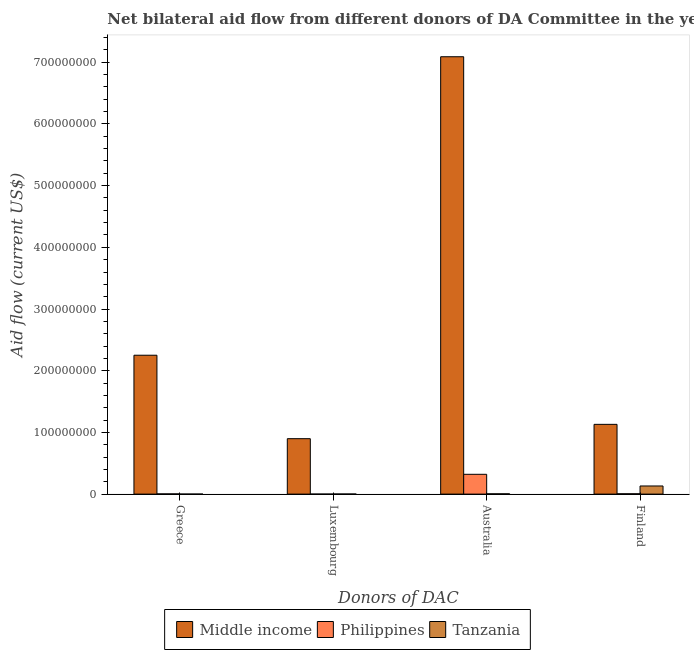How many different coloured bars are there?
Offer a terse response. 3. Are the number of bars per tick equal to the number of legend labels?
Ensure brevity in your answer.  Yes. Are the number of bars on each tick of the X-axis equal?
Your answer should be compact. Yes. How many bars are there on the 4th tick from the left?
Offer a very short reply. 3. How many bars are there on the 3rd tick from the right?
Your response must be concise. 3. What is the label of the 2nd group of bars from the left?
Give a very brief answer. Luxembourg. What is the amount of aid given by luxembourg in Middle income?
Offer a terse response. 8.98e+07. Across all countries, what is the maximum amount of aid given by finland?
Offer a terse response. 1.13e+08. Across all countries, what is the minimum amount of aid given by luxembourg?
Your answer should be very brief. 10000. In which country was the amount of aid given by luxembourg minimum?
Ensure brevity in your answer.  Philippines. What is the total amount of aid given by greece in the graph?
Keep it short and to the point. 2.25e+08. What is the difference between the amount of aid given by finland in Tanzania and that in Philippines?
Make the answer very short. 1.26e+07. What is the difference between the amount of aid given by greece in Middle income and the amount of aid given by finland in Tanzania?
Give a very brief answer. 2.12e+08. What is the average amount of aid given by australia per country?
Offer a very short reply. 2.47e+08. What is the difference between the amount of aid given by finland and amount of aid given by greece in Tanzania?
Ensure brevity in your answer.  1.32e+07. What is the ratio of the amount of aid given by australia in Middle income to that in Philippines?
Give a very brief answer. 22.1. What is the difference between the highest and the second highest amount of aid given by luxembourg?
Offer a terse response. 8.97e+07. What is the difference between the highest and the lowest amount of aid given by greece?
Offer a terse response. 2.25e+08. Is the sum of the amount of aid given by finland in Philippines and Tanzania greater than the maximum amount of aid given by greece across all countries?
Offer a very short reply. No. Is it the case that in every country, the sum of the amount of aid given by luxembourg and amount of aid given by greece is greater than the sum of amount of aid given by australia and amount of aid given by finland?
Offer a terse response. No. Are all the bars in the graph horizontal?
Keep it short and to the point. No. Are the values on the major ticks of Y-axis written in scientific E-notation?
Provide a short and direct response. No. Does the graph contain any zero values?
Offer a very short reply. No. Does the graph contain grids?
Give a very brief answer. No. Where does the legend appear in the graph?
Your response must be concise. Bottom center. How many legend labels are there?
Your answer should be very brief. 3. How are the legend labels stacked?
Provide a succinct answer. Horizontal. What is the title of the graph?
Your answer should be compact. Net bilateral aid flow from different donors of DA Committee in the year 2003. Does "Lower middle income" appear as one of the legend labels in the graph?
Provide a short and direct response. No. What is the label or title of the X-axis?
Provide a short and direct response. Donors of DAC. What is the label or title of the Y-axis?
Offer a very short reply. Aid flow (current US$). What is the Aid flow (current US$) in Middle income in Greece?
Make the answer very short. 2.25e+08. What is the Aid flow (current US$) of Philippines in Greece?
Offer a terse response. 3.20e+05. What is the Aid flow (current US$) in Middle income in Luxembourg?
Your answer should be compact. 8.98e+07. What is the Aid flow (current US$) of Philippines in Luxembourg?
Provide a short and direct response. 10000. What is the Aid flow (current US$) in Tanzania in Luxembourg?
Ensure brevity in your answer.  1.40e+05. What is the Aid flow (current US$) of Middle income in Australia?
Your response must be concise. 7.09e+08. What is the Aid flow (current US$) in Philippines in Australia?
Offer a terse response. 3.21e+07. What is the Aid flow (current US$) in Middle income in Finland?
Provide a succinct answer. 1.13e+08. What is the Aid flow (current US$) of Philippines in Finland?
Offer a very short reply. 5.40e+05. What is the Aid flow (current US$) in Tanzania in Finland?
Offer a very short reply. 1.32e+07. Across all Donors of DAC, what is the maximum Aid flow (current US$) of Middle income?
Give a very brief answer. 7.09e+08. Across all Donors of DAC, what is the maximum Aid flow (current US$) in Philippines?
Give a very brief answer. 3.21e+07. Across all Donors of DAC, what is the maximum Aid flow (current US$) of Tanzania?
Your answer should be very brief. 1.32e+07. Across all Donors of DAC, what is the minimum Aid flow (current US$) in Middle income?
Offer a terse response. 8.98e+07. Across all Donors of DAC, what is the minimum Aid flow (current US$) in Philippines?
Ensure brevity in your answer.  10000. What is the total Aid flow (current US$) in Middle income in the graph?
Ensure brevity in your answer.  1.14e+09. What is the total Aid flow (current US$) of Philippines in the graph?
Ensure brevity in your answer.  3.30e+07. What is the total Aid flow (current US$) in Tanzania in the graph?
Provide a short and direct response. 1.38e+07. What is the difference between the Aid flow (current US$) in Middle income in Greece and that in Luxembourg?
Your answer should be compact. 1.35e+08. What is the difference between the Aid flow (current US$) in Philippines in Greece and that in Luxembourg?
Ensure brevity in your answer.  3.10e+05. What is the difference between the Aid flow (current US$) of Tanzania in Greece and that in Luxembourg?
Ensure brevity in your answer.  -1.20e+05. What is the difference between the Aid flow (current US$) of Middle income in Greece and that in Australia?
Provide a short and direct response. -4.84e+08. What is the difference between the Aid flow (current US$) of Philippines in Greece and that in Australia?
Make the answer very short. -3.18e+07. What is the difference between the Aid flow (current US$) of Tanzania in Greece and that in Australia?
Provide a short and direct response. -4.50e+05. What is the difference between the Aid flow (current US$) in Middle income in Greece and that in Finland?
Offer a very short reply. 1.12e+08. What is the difference between the Aid flow (current US$) in Tanzania in Greece and that in Finland?
Give a very brief answer. -1.32e+07. What is the difference between the Aid flow (current US$) in Middle income in Luxembourg and that in Australia?
Provide a short and direct response. -6.19e+08. What is the difference between the Aid flow (current US$) in Philippines in Luxembourg and that in Australia?
Your answer should be compact. -3.21e+07. What is the difference between the Aid flow (current US$) of Tanzania in Luxembourg and that in Australia?
Keep it short and to the point. -3.30e+05. What is the difference between the Aid flow (current US$) of Middle income in Luxembourg and that in Finland?
Provide a succinct answer. -2.32e+07. What is the difference between the Aid flow (current US$) of Philippines in Luxembourg and that in Finland?
Offer a very short reply. -5.30e+05. What is the difference between the Aid flow (current US$) in Tanzania in Luxembourg and that in Finland?
Give a very brief answer. -1.30e+07. What is the difference between the Aid flow (current US$) of Middle income in Australia and that in Finland?
Your answer should be very brief. 5.96e+08. What is the difference between the Aid flow (current US$) of Philippines in Australia and that in Finland?
Your answer should be compact. 3.15e+07. What is the difference between the Aid flow (current US$) in Tanzania in Australia and that in Finland?
Offer a very short reply. -1.27e+07. What is the difference between the Aid flow (current US$) of Middle income in Greece and the Aid flow (current US$) of Philippines in Luxembourg?
Offer a terse response. 2.25e+08. What is the difference between the Aid flow (current US$) in Middle income in Greece and the Aid flow (current US$) in Tanzania in Luxembourg?
Ensure brevity in your answer.  2.25e+08. What is the difference between the Aid flow (current US$) in Philippines in Greece and the Aid flow (current US$) in Tanzania in Luxembourg?
Provide a succinct answer. 1.80e+05. What is the difference between the Aid flow (current US$) of Middle income in Greece and the Aid flow (current US$) of Philippines in Australia?
Your response must be concise. 1.93e+08. What is the difference between the Aid flow (current US$) in Middle income in Greece and the Aid flow (current US$) in Tanzania in Australia?
Your answer should be compact. 2.25e+08. What is the difference between the Aid flow (current US$) in Philippines in Greece and the Aid flow (current US$) in Tanzania in Australia?
Give a very brief answer. -1.50e+05. What is the difference between the Aid flow (current US$) in Middle income in Greece and the Aid flow (current US$) in Philippines in Finland?
Give a very brief answer. 2.25e+08. What is the difference between the Aid flow (current US$) in Middle income in Greece and the Aid flow (current US$) in Tanzania in Finland?
Offer a terse response. 2.12e+08. What is the difference between the Aid flow (current US$) of Philippines in Greece and the Aid flow (current US$) of Tanzania in Finland?
Offer a terse response. -1.28e+07. What is the difference between the Aid flow (current US$) of Middle income in Luxembourg and the Aid flow (current US$) of Philippines in Australia?
Keep it short and to the point. 5.78e+07. What is the difference between the Aid flow (current US$) in Middle income in Luxembourg and the Aid flow (current US$) in Tanzania in Australia?
Provide a short and direct response. 8.94e+07. What is the difference between the Aid flow (current US$) of Philippines in Luxembourg and the Aid flow (current US$) of Tanzania in Australia?
Make the answer very short. -4.60e+05. What is the difference between the Aid flow (current US$) of Middle income in Luxembourg and the Aid flow (current US$) of Philippines in Finland?
Your answer should be very brief. 8.93e+07. What is the difference between the Aid flow (current US$) of Middle income in Luxembourg and the Aid flow (current US$) of Tanzania in Finland?
Provide a succinct answer. 7.67e+07. What is the difference between the Aid flow (current US$) of Philippines in Luxembourg and the Aid flow (current US$) of Tanzania in Finland?
Offer a terse response. -1.32e+07. What is the difference between the Aid flow (current US$) of Middle income in Australia and the Aid flow (current US$) of Philippines in Finland?
Your answer should be compact. 7.08e+08. What is the difference between the Aid flow (current US$) of Middle income in Australia and the Aid flow (current US$) of Tanzania in Finland?
Give a very brief answer. 6.96e+08. What is the difference between the Aid flow (current US$) of Philippines in Australia and the Aid flow (current US$) of Tanzania in Finland?
Provide a succinct answer. 1.89e+07. What is the average Aid flow (current US$) of Middle income per Donors of DAC?
Make the answer very short. 2.84e+08. What is the average Aid flow (current US$) of Philippines per Donors of DAC?
Give a very brief answer. 8.24e+06. What is the average Aid flow (current US$) in Tanzania per Donors of DAC?
Offer a very short reply. 3.45e+06. What is the difference between the Aid flow (current US$) of Middle income and Aid flow (current US$) of Philippines in Greece?
Keep it short and to the point. 2.25e+08. What is the difference between the Aid flow (current US$) of Middle income and Aid flow (current US$) of Tanzania in Greece?
Your response must be concise. 2.25e+08. What is the difference between the Aid flow (current US$) of Middle income and Aid flow (current US$) of Philippines in Luxembourg?
Provide a short and direct response. 8.98e+07. What is the difference between the Aid flow (current US$) of Middle income and Aid flow (current US$) of Tanzania in Luxembourg?
Provide a short and direct response. 8.97e+07. What is the difference between the Aid flow (current US$) of Middle income and Aid flow (current US$) of Philippines in Australia?
Your answer should be compact. 6.77e+08. What is the difference between the Aid flow (current US$) of Middle income and Aid flow (current US$) of Tanzania in Australia?
Offer a terse response. 7.08e+08. What is the difference between the Aid flow (current US$) of Philippines and Aid flow (current US$) of Tanzania in Australia?
Keep it short and to the point. 3.16e+07. What is the difference between the Aid flow (current US$) of Middle income and Aid flow (current US$) of Philippines in Finland?
Provide a succinct answer. 1.13e+08. What is the difference between the Aid flow (current US$) of Middle income and Aid flow (current US$) of Tanzania in Finland?
Keep it short and to the point. 9.99e+07. What is the difference between the Aid flow (current US$) in Philippines and Aid flow (current US$) in Tanzania in Finland?
Your answer should be compact. -1.26e+07. What is the ratio of the Aid flow (current US$) of Middle income in Greece to that in Luxembourg?
Your response must be concise. 2.51. What is the ratio of the Aid flow (current US$) of Philippines in Greece to that in Luxembourg?
Offer a terse response. 32. What is the ratio of the Aid flow (current US$) in Tanzania in Greece to that in Luxembourg?
Your answer should be very brief. 0.14. What is the ratio of the Aid flow (current US$) of Middle income in Greece to that in Australia?
Ensure brevity in your answer.  0.32. What is the ratio of the Aid flow (current US$) of Philippines in Greece to that in Australia?
Keep it short and to the point. 0.01. What is the ratio of the Aid flow (current US$) in Tanzania in Greece to that in Australia?
Offer a very short reply. 0.04. What is the ratio of the Aid flow (current US$) of Middle income in Greece to that in Finland?
Provide a short and direct response. 1.99. What is the ratio of the Aid flow (current US$) in Philippines in Greece to that in Finland?
Your answer should be very brief. 0.59. What is the ratio of the Aid flow (current US$) of Tanzania in Greece to that in Finland?
Keep it short and to the point. 0. What is the ratio of the Aid flow (current US$) in Middle income in Luxembourg to that in Australia?
Offer a terse response. 0.13. What is the ratio of the Aid flow (current US$) of Tanzania in Luxembourg to that in Australia?
Provide a short and direct response. 0.3. What is the ratio of the Aid flow (current US$) in Middle income in Luxembourg to that in Finland?
Your answer should be compact. 0.79. What is the ratio of the Aid flow (current US$) in Philippines in Luxembourg to that in Finland?
Make the answer very short. 0.02. What is the ratio of the Aid flow (current US$) in Tanzania in Luxembourg to that in Finland?
Offer a terse response. 0.01. What is the ratio of the Aid flow (current US$) in Middle income in Australia to that in Finland?
Offer a very short reply. 6.27. What is the ratio of the Aid flow (current US$) of Philippines in Australia to that in Finland?
Your answer should be compact. 59.41. What is the ratio of the Aid flow (current US$) of Tanzania in Australia to that in Finland?
Provide a succinct answer. 0.04. What is the difference between the highest and the second highest Aid flow (current US$) in Middle income?
Keep it short and to the point. 4.84e+08. What is the difference between the highest and the second highest Aid flow (current US$) of Philippines?
Offer a terse response. 3.15e+07. What is the difference between the highest and the second highest Aid flow (current US$) in Tanzania?
Ensure brevity in your answer.  1.27e+07. What is the difference between the highest and the lowest Aid flow (current US$) of Middle income?
Your response must be concise. 6.19e+08. What is the difference between the highest and the lowest Aid flow (current US$) of Philippines?
Give a very brief answer. 3.21e+07. What is the difference between the highest and the lowest Aid flow (current US$) in Tanzania?
Your response must be concise. 1.32e+07. 